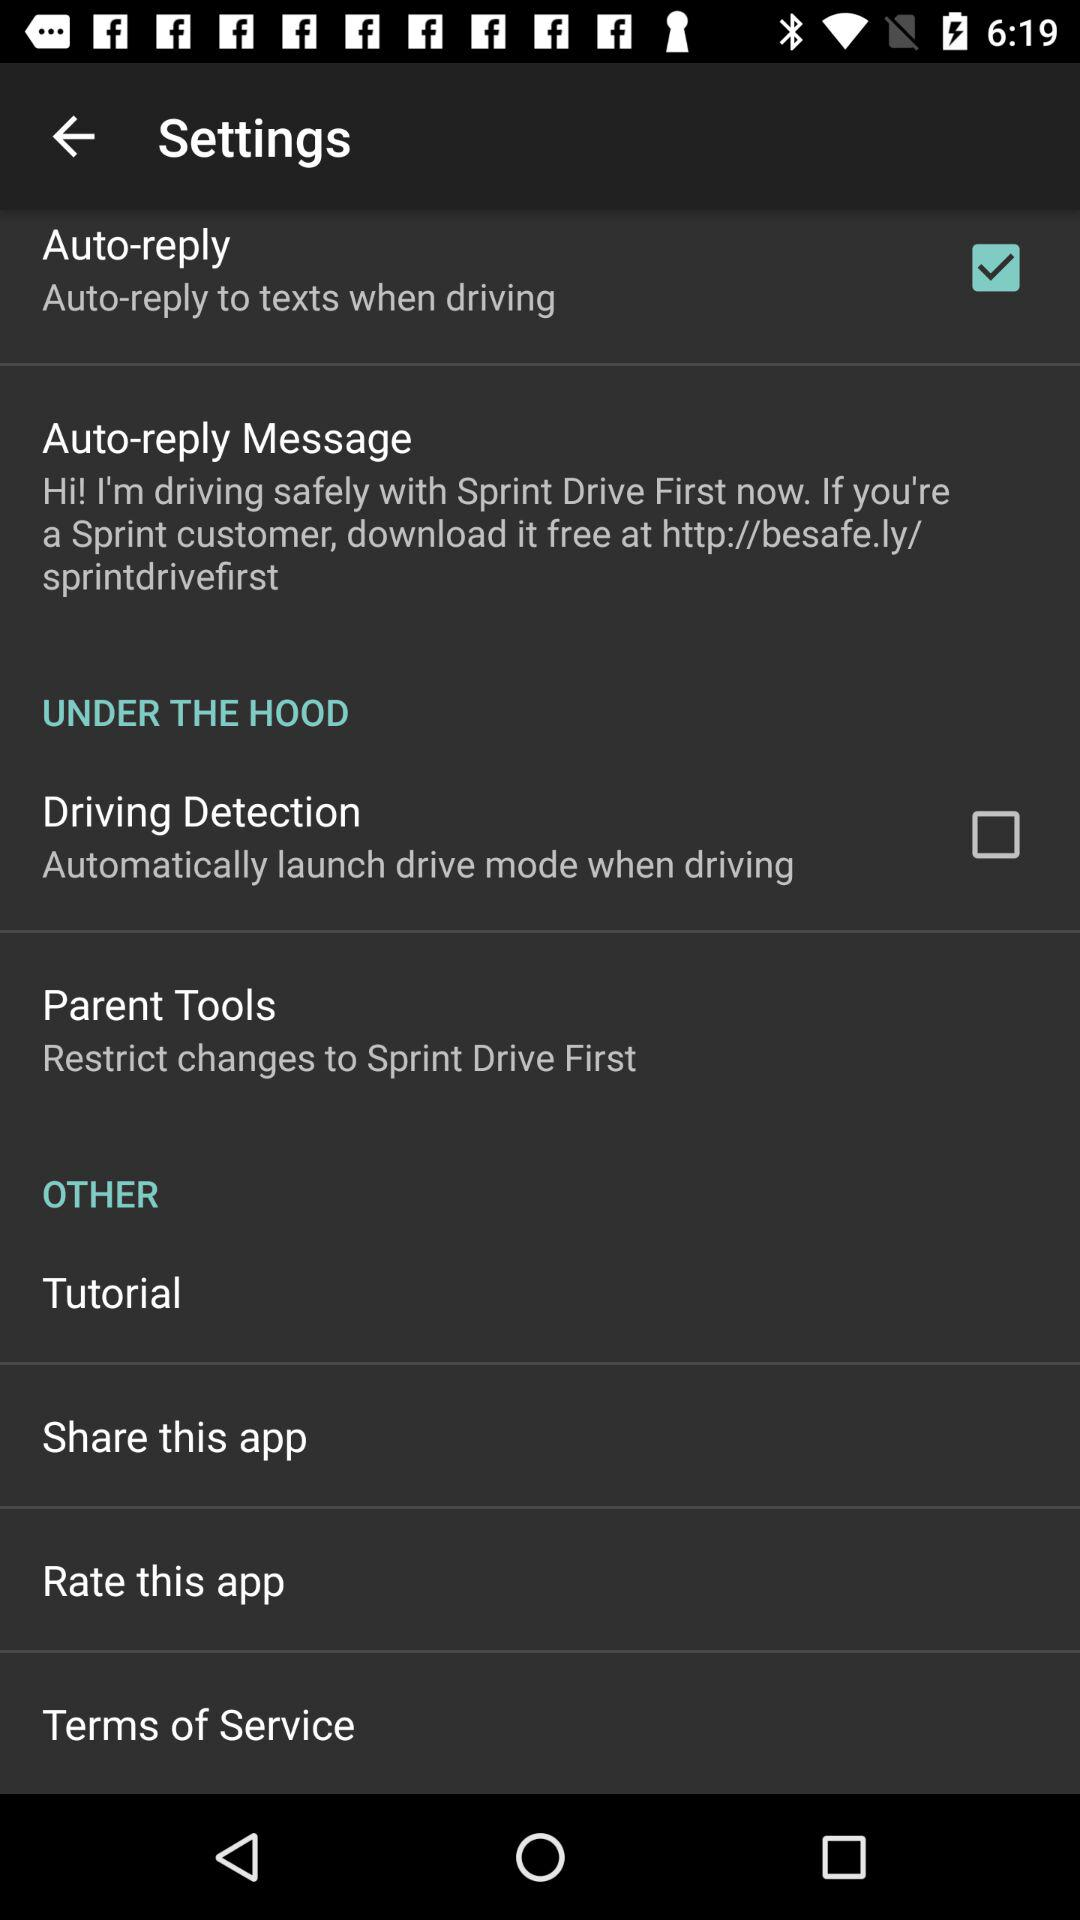How many items are under the Other section?
Answer the question using a single word or phrase. 4 